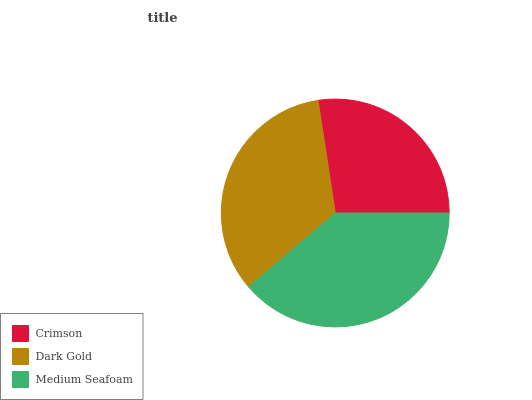Is Crimson the minimum?
Answer yes or no. Yes. Is Medium Seafoam the maximum?
Answer yes or no. Yes. Is Dark Gold the minimum?
Answer yes or no. No. Is Dark Gold the maximum?
Answer yes or no. No. Is Dark Gold greater than Crimson?
Answer yes or no. Yes. Is Crimson less than Dark Gold?
Answer yes or no. Yes. Is Crimson greater than Dark Gold?
Answer yes or no. No. Is Dark Gold less than Crimson?
Answer yes or no. No. Is Dark Gold the high median?
Answer yes or no. Yes. Is Dark Gold the low median?
Answer yes or no. Yes. Is Medium Seafoam the high median?
Answer yes or no. No. Is Crimson the low median?
Answer yes or no. No. 